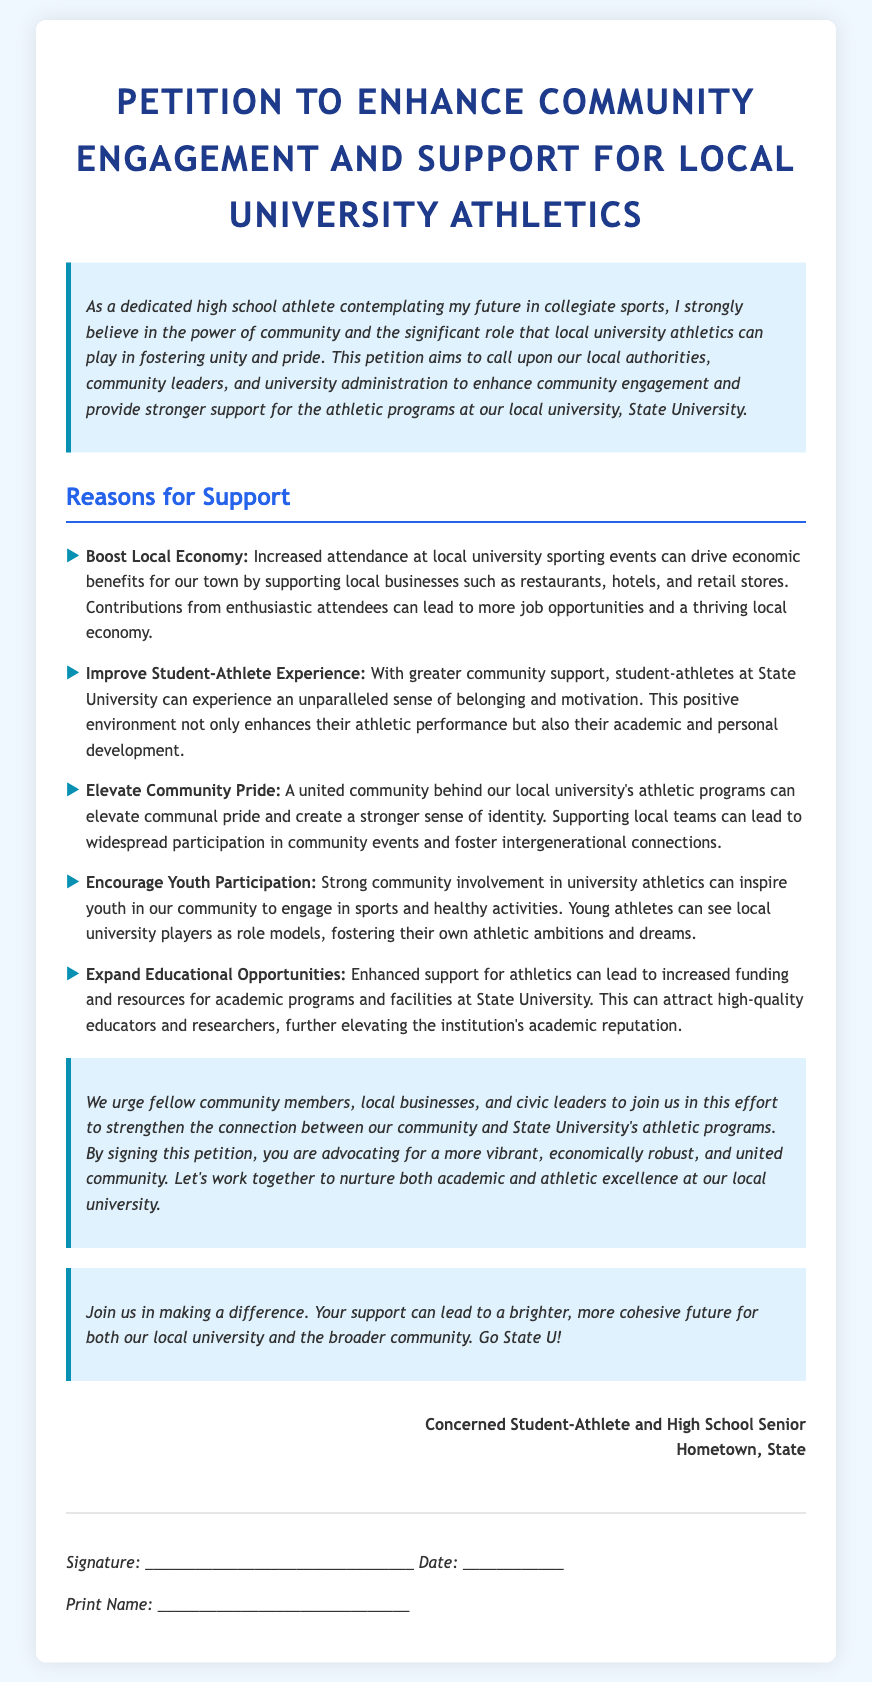What is the title of the petition? The title of the petition is prominently displayed at the top of the document.
Answer: Petition to Enhance Community Engagement and Support for Local University Athletics Who is the concerned author of the petition? The author of the petition is mentioned in the sign-off section.
Answer: Concerned Student-Athlete and High School Senior What is one of the economic benefits mentioned? The petition lists economic impacts in the reasons for support section.
Answer: Boost Local Economy How many key reasons for support are outlined in the petition? The number of reasons for support can be counted in the list provided.
Answer: Five What is the primary university discussed in the petition? The specific university referenced throughout the petition is named in the introduction.
Answer: State University What type of engagement does the petition advocate for? The petition emphasizes a certain type of engagement in its title and introductory statement.
Answer: Community Engagement Which phrase indicates a call to action in the petition? The phrase indicating a call to action can be found in the call-to-action section.
Answer: Join us in making a difference How does the petition suggest enhancing the student-athlete experience? The petition addresses improving the student-athlete experience as one of the reasons for support.
Answer: Improve Student-Athlete Experience 